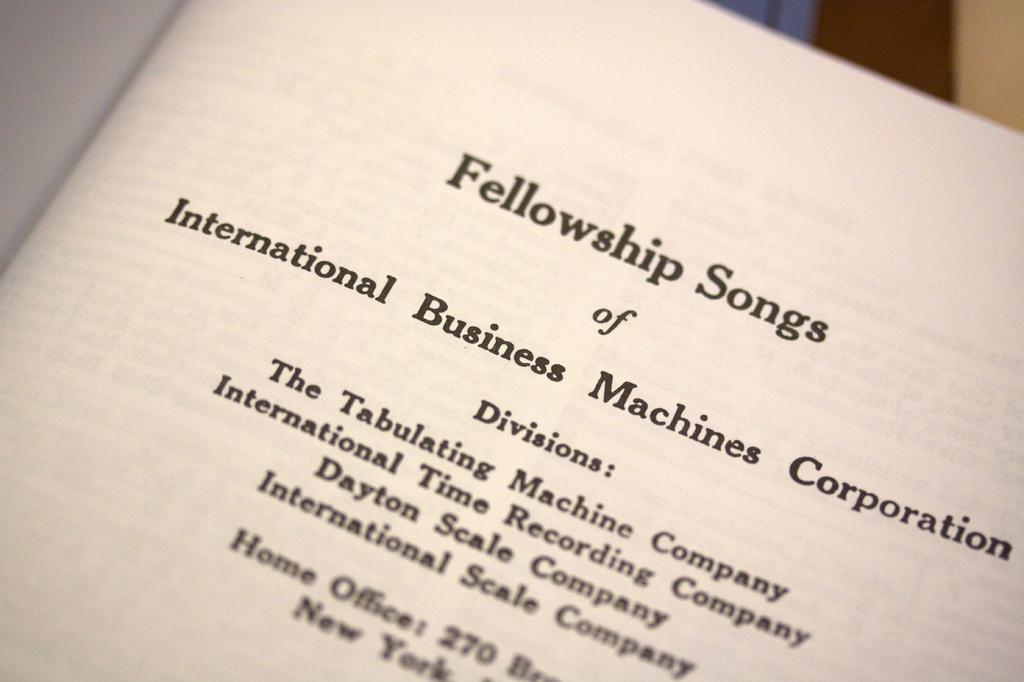<image>
Provide a brief description of the given image. A book is open and the title Fellowship Songs is at the top of the page. 